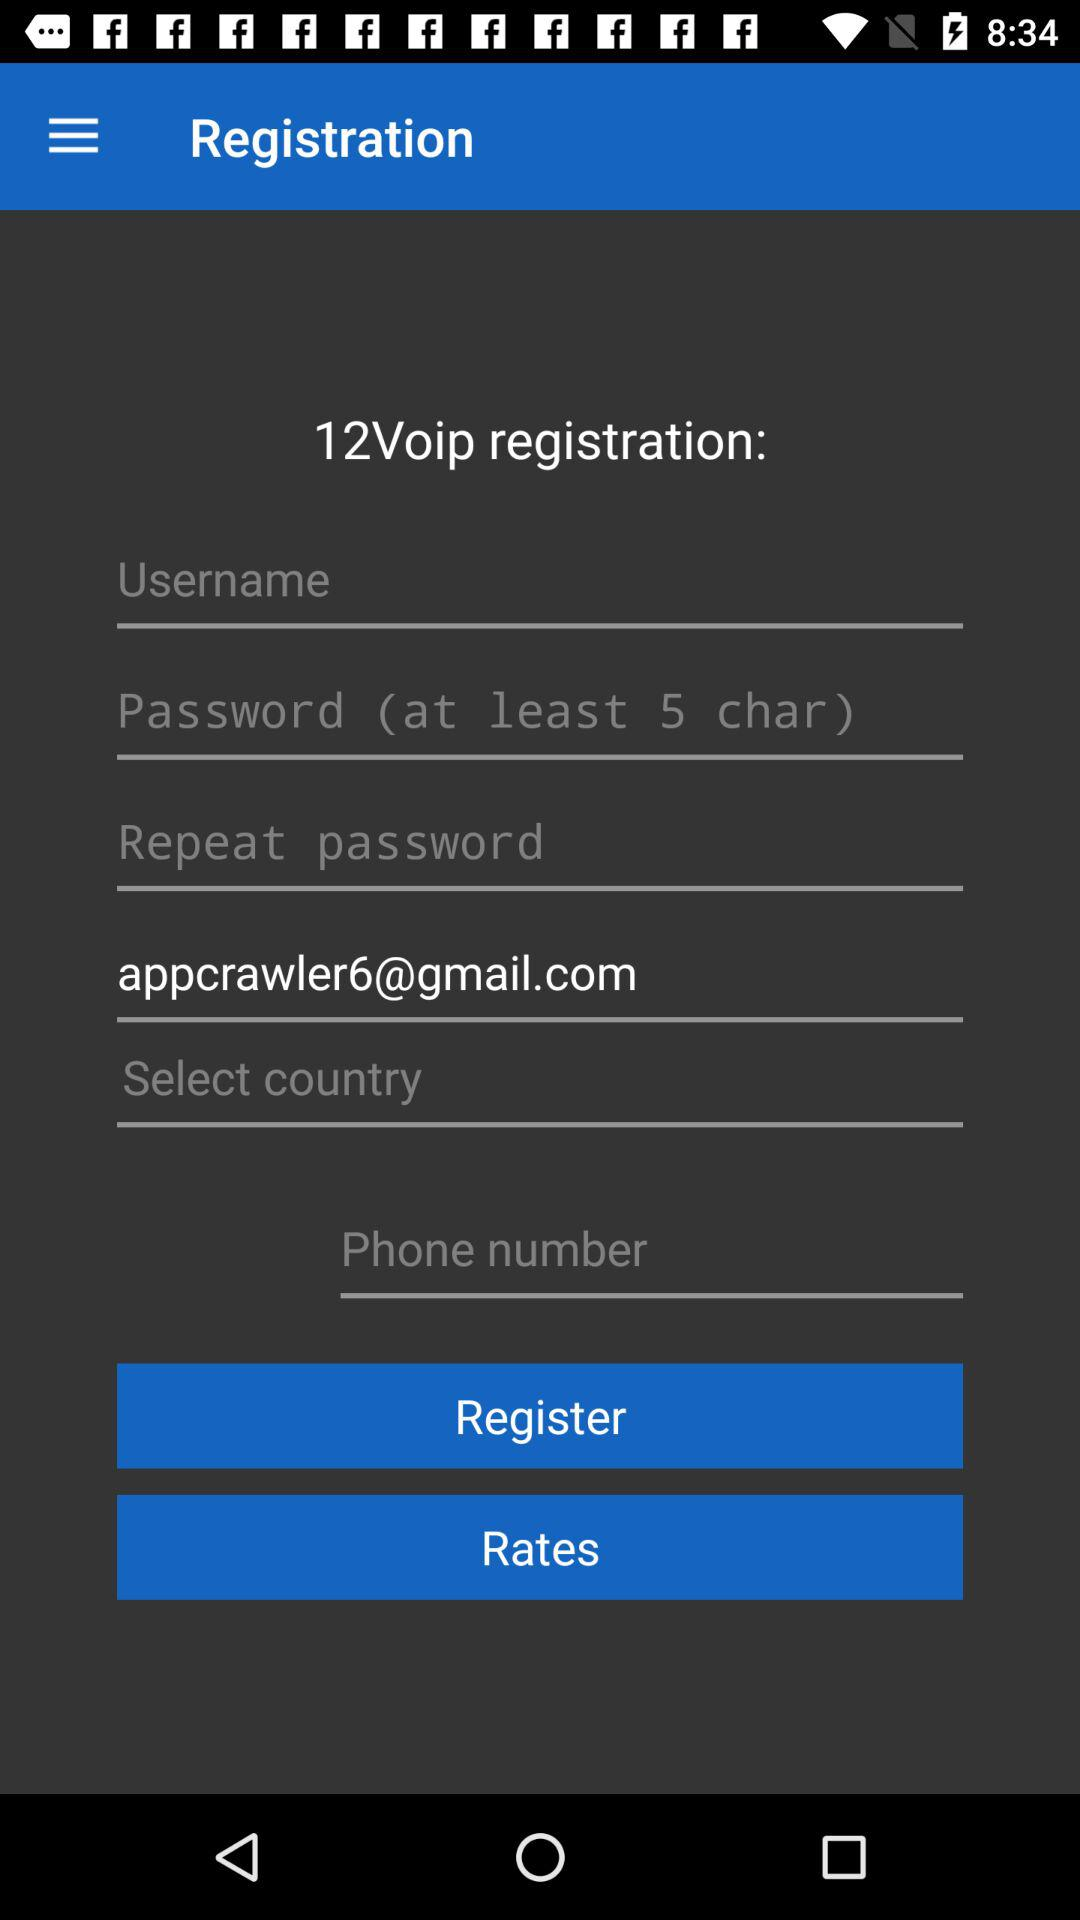What is the length of the password? The password length is at least 5 characters. 